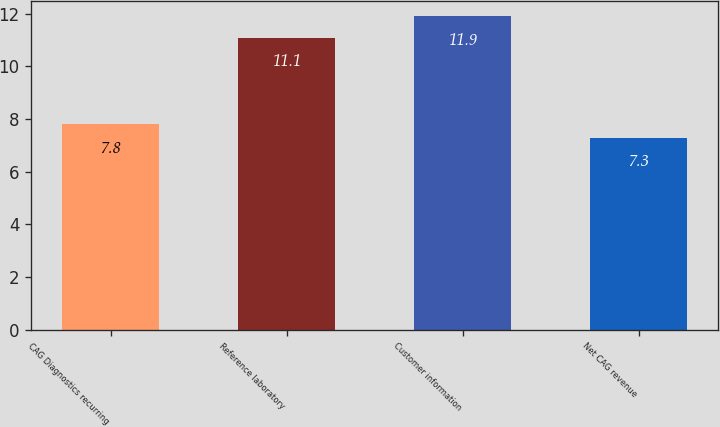Convert chart to OTSL. <chart><loc_0><loc_0><loc_500><loc_500><bar_chart><fcel>CAG Diagnostics recurring<fcel>Reference laboratory<fcel>Customer information<fcel>Net CAG revenue<nl><fcel>7.8<fcel>11.1<fcel>11.9<fcel>7.3<nl></chart> 